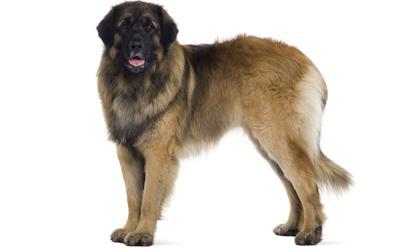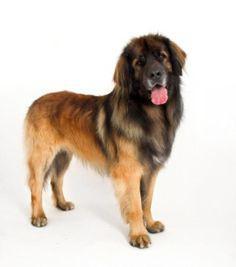The first image is the image on the left, the second image is the image on the right. For the images shown, is this caption "A dog is on a ground filled with snow." true? Answer yes or no. No. The first image is the image on the left, the second image is the image on the right. For the images shown, is this caption "One image shows a dog on snow-covered ground." true? Answer yes or no. No. 